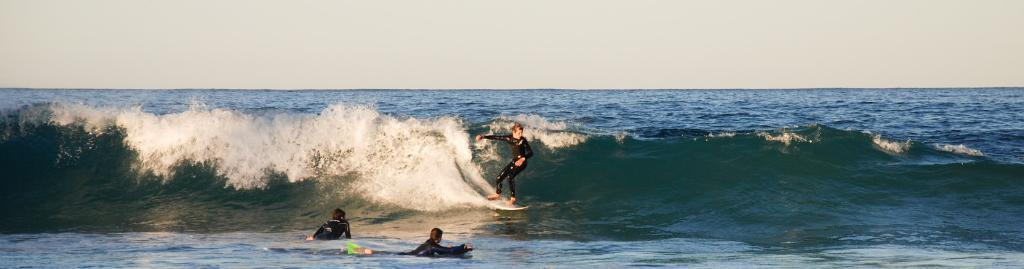Who is present in the image? There are people in the image. What are the people doing in the image? The people are surfing in the image. Where is the surfing taking place? The surfing is taking place in an ocean. What can be seen above the ocean in the image? The sky is visible at the top of the image. How many oranges are being used as surfboards in the image? There are no oranges present in the image, and they are not being used as surfboards. What type of tent can be seen in the image? There is no tent present in the image. 